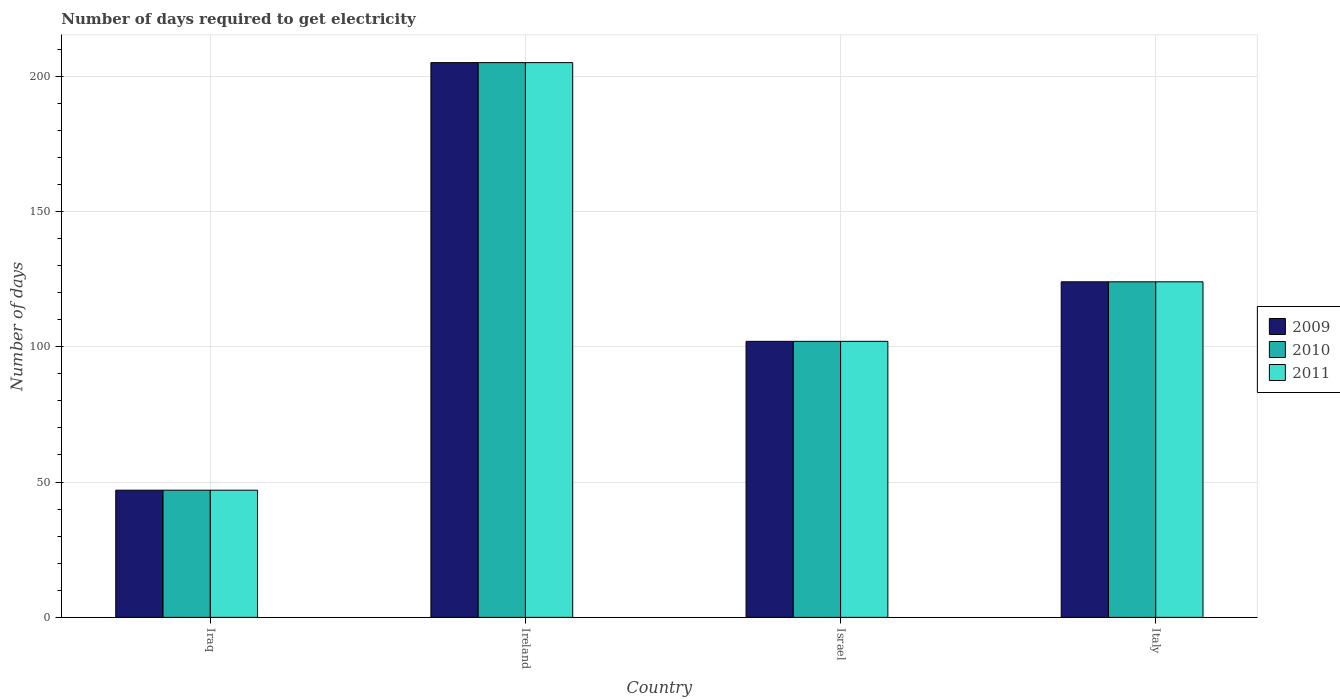How many different coloured bars are there?
Offer a very short reply. 3. How many groups of bars are there?
Make the answer very short. 4. Are the number of bars per tick equal to the number of legend labels?
Offer a terse response. Yes. In how many cases, is the number of bars for a given country not equal to the number of legend labels?
Keep it short and to the point. 0. Across all countries, what is the maximum number of days required to get electricity in in 2009?
Provide a succinct answer. 205. Across all countries, what is the minimum number of days required to get electricity in in 2009?
Offer a very short reply. 47. In which country was the number of days required to get electricity in in 2010 maximum?
Provide a short and direct response. Ireland. In which country was the number of days required to get electricity in in 2009 minimum?
Provide a succinct answer. Iraq. What is the total number of days required to get electricity in in 2011 in the graph?
Give a very brief answer. 478. What is the difference between the number of days required to get electricity in in 2010 in Ireland and that in Israel?
Make the answer very short. 103. What is the difference between the number of days required to get electricity in in 2011 in Iraq and the number of days required to get electricity in in 2009 in Italy?
Your response must be concise. -77. What is the average number of days required to get electricity in in 2009 per country?
Your response must be concise. 119.5. What is the difference between the number of days required to get electricity in of/in 2010 and number of days required to get electricity in of/in 2011 in Italy?
Give a very brief answer. 0. What is the ratio of the number of days required to get electricity in in 2009 in Israel to that in Italy?
Your response must be concise. 0.82. What is the difference between the highest and the second highest number of days required to get electricity in in 2010?
Keep it short and to the point. -81. What is the difference between the highest and the lowest number of days required to get electricity in in 2009?
Your answer should be compact. 158. Is it the case that in every country, the sum of the number of days required to get electricity in in 2009 and number of days required to get electricity in in 2011 is greater than the number of days required to get electricity in in 2010?
Make the answer very short. Yes. How many bars are there?
Your answer should be compact. 12. Are all the bars in the graph horizontal?
Offer a terse response. No. How many countries are there in the graph?
Your answer should be very brief. 4. What is the difference between two consecutive major ticks on the Y-axis?
Your response must be concise. 50. Where does the legend appear in the graph?
Make the answer very short. Center right. How many legend labels are there?
Provide a succinct answer. 3. How are the legend labels stacked?
Keep it short and to the point. Vertical. What is the title of the graph?
Your answer should be very brief. Number of days required to get electricity. Does "2005" appear as one of the legend labels in the graph?
Your answer should be very brief. No. What is the label or title of the X-axis?
Your answer should be very brief. Country. What is the label or title of the Y-axis?
Offer a terse response. Number of days. What is the Number of days in 2009 in Iraq?
Offer a very short reply. 47. What is the Number of days of 2010 in Iraq?
Offer a very short reply. 47. What is the Number of days of 2011 in Iraq?
Keep it short and to the point. 47. What is the Number of days of 2009 in Ireland?
Offer a very short reply. 205. What is the Number of days of 2010 in Ireland?
Give a very brief answer. 205. What is the Number of days of 2011 in Ireland?
Make the answer very short. 205. What is the Number of days of 2009 in Israel?
Offer a terse response. 102. What is the Number of days in 2010 in Israel?
Your answer should be compact. 102. What is the Number of days of 2011 in Israel?
Make the answer very short. 102. What is the Number of days in 2009 in Italy?
Your answer should be very brief. 124. What is the Number of days of 2010 in Italy?
Provide a succinct answer. 124. What is the Number of days in 2011 in Italy?
Keep it short and to the point. 124. Across all countries, what is the maximum Number of days in 2009?
Give a very brief answer. 205. Across all countries, what is the maximum Number of days of 2010?
Your answer should be very brief. 205. Across all countries, what is the maximum Number of days of 2011?
Make the answer very short. 205. Across all countries, what is the minimum Number of days in 2009?
Provide a succinct answer. 47. Across all countries, what is the minimum Number of days of 2010?
Your response must be concise. 47. What is the total Number of days in 2009 in the graph?
Offer a very short reply. 478. What is the total Number of days of 2010 in the graph?
Your answer should be very brief. 478. What is the total Number of days in 2011 in the graph?
Offer a terse response. 478. What is the difference between the Number of days of 2009 in Iraq and that in Ireland?
Offer a very short reply. -158. What is the difference between the Number of days in 2010 in Iraq and that in Ireland?
Offer a very short reply. -158. What is the difference between the Number of days in 2011 in Iraq and that in Ireland?
Your answer should be compact. -158. What is the difference between the Number of days of 2009 in Iraq and that in Israel?
Your answer should be very brief. -55. What is the difference between the Number of days of 2010 in Iraq and that in Israel?
Ensure brevity in your answer.  -55. What is the difference between the Number of days of 2011 in Iraq and that in Israel?
Ensure brevity in your answer.  -55. What is the difference between the Number of days of 2009 in Iraq and that in Italy?
Give a very brief answer. -77. What is the difference between the Number of days of 2010 in Iraq and that in Italy?
Your response must be concise. -77. What is the difference between the Number of days in 2011 in Iraq and that in Italy?
Offer a very short reply. -77. What is the difference between the Number of days in 2009 in Ireland and that in Israel?
Your answer should be compact. 103. What is the difference between the Number of days in 2010 in Ireland and that in Israel?
Offer a very short reply. 103. What is the difference between the Number of days in 2011 in Ireland and that in Israel?
Keep it short and to the point. 103. What is the difference between the Number of days of 2009 in Ireland and that in Italy?
Provide a short and direct response. 81. What is the difference between the Number of days of 2010 in Ireland and that in Italy?
Ensure brevity in your answer.  81. What is the difference between the Number of days in 2009 in Israel and that in Italy?
Provide a succinct answer. -22. What is the difference between the Number of days in 2011 in Israel and that in Italy?
Offer a very short reply. -22. What is the difference between the Number of days of 2009 in Iraq and the Number of days of 2010 in Ireland?
Offer a terse response. -158. What is the difference between the Number of days in 2009 in Iraq and the Number of days in 2011 in Ireland?
Offer a terse response. -158. What is the difference between the Number of days in 2010 in Iraq and the Number of days in 2011 in Ireland?
Make the answer very short. -158. What is the difference between the Number of days in 2009 in Iraq and the Number of days in 2010 in Israel?
Keep it short and to the point. -55. What is the difference between the Number of days in 2009 in Iraq and the Number of days in 2011 in Israel?
Offer a terse response. -55. What is the difference between the Number of days in 2010 in Iraq and the Number of days in 2011 in Israel?
Your answer should be compact. -55. What is the difference between the Number of days in 2009 in Iraq and the Number of days in 2010 in Italy?
Your response must be concise. -77. What is the difference between the Number of days in 2009 in Iraq and the Number of days in 2011 in Italy?
Offer a terse response. -77. What is the difference between the Number of days in 2010 in Iraq and the Number of days in 2011 in Italy?
Your answer should be compact. -77. What is the difference between the Number of days of 2009 in Ireland and the Number of days of 2010 in Israel?
Provide a short and direct response. 103. What is the difference between the Number of days in 2009 in Ireland and the Number of days in 2011 in Israel?
Give a very brief answer. 103. What is the difference between the Number of days of 2010 in Ireland and the Number of days of 2011 in Israel?
Offer a terse response. 103. What is the difference between the Number of days in 2009 in Ireland and the Number of days in 2010 in Italy?
Make the answer very short. 81. What is the difference between the Number of days of 2009 in Ireland and the Number of days of 2011 in Italy?
Keep it short and to the point. 81. What is the difference between the Number of days of 2009 in Israel and the Number of days of 2010 in Italy?
Ensure brevity in your answer.  -22. What is the difference between the Number of days of 2009 in Israel and the Number of days of 2011 in Italy?
Ensure brevity in your answer.  -22. What is the average Number of days in 2009 per country?
Make the answer very short. 119.5. What is the average Number of days of 2010 per country?
Offer a terse response. 119.5. What is the average Number of days in 2011 per country?
Provide a succinct answer. 119.5. What is the difference between the Number of days of 2009 and Number of days of 2011 in Iraq?
Your answer should be very brief. 0. What is the difference between the Number of days of 2010 and Number of days of 2011 in Iraq?
Your answer should be very brief. 0. What is the difference between the Number of days in 2009 and Number of days in 2010 in Ireland?
Give a very brief answer. 0. What is the difference between the Number of days of 2009 and Number of days of 2011 in Ireland?
Keep it short and to the point. 0. What is the difference between the Number of days in 2009 and Number of days in 2011 in Israel?
Your response must be concise. 0. What is the difference between the Number of days of 2009 and Number of days of 2010 in Italy?
Your response must be concise. 0. What is the difference between the Number of days of 2010 and Number of days of 2011 in Italy?
Offer a very short reply. 0. What is the ratio of the Number of days in 2009 in Iraq to that in Ireland?
Your answer should be compact. 0.23. What is the ratio of the Number of days of 2010 in Iraq to that in Ireland?
Provide a succinct answer. 0.23. What is the ratio of the Number of days of 2011 in Iraq to that in Ireland?
Your answer should be very brief. 0.23. What is the ratio of the Number of days in 2009 in Iraq to that in Israel?
Keep it short and to the point. 0.46. What is the ratio of the Number of days in 2010 in Iraq to that in Israel?
Keep it short and to the point. 0.46. What is the ratio of the Number of days in 2011 in Iraq to that in Israel?
Give a very brief answer. 0.46. What is the ratio of the Number of days in 2009 in Iraq to that in Italy?
Make the answer very short. 0.38. What is the ratio of the Number of days in 2010 in Iraq to that in Italy?
Provide a succinct answer. 0.38. What is the ratio of the Number of days of 2011 in Iraq to that in Italy?
Give a very brief answer. 0.38. What is the ratio of the Number of days in 2009 in Ireland to that in Israel?
Give a very brief answer. 2.01. What is the ratio of the Number of days in 2010 in Ireland to that in Israel?
Keep it short and to the point. 2.01. What is the ratio of the Number of days of 2011 in Ireland to that in Israel?
Your response must be concise. 2.01. What is the ratio of the Number of days of 2009 in Ireland to that in Italy?
Ensure brevity in your answer.  1.65. What is the ratio of the Number of days of 2010 in Ireland to that in Italy?
Offer a very short reply. 1.65. What is the ratio of the Number of days of 2011 in Ireland to that in Italy?
Give a very brief answer. 1.65. What is the ratio of the Number of days of 2009 in Israel to that in Italy?
Your response must be concise. 0.82. What is the ratio of the Number of days in 2010 in Israel to that in Italy?
Your answer should be very brief. 0.82. What is the ratio of the Number of days in 2011 in Israel to that in Italy?
Provide a short and direct response. 0.82. What is the difference between the highest and the second highest Number of days of 2009?
Provide a succinct answer. 81. What is the difference between the highest and the lowest Number of days of 2009?
Make the answer very short. 158. What is the difference between the highest and the lowest Number of days of 2010?
Your response must be concise. 158. What is the difference between the highest and the lowest Number of days in 2011?
Offer a very short reply. 158. 